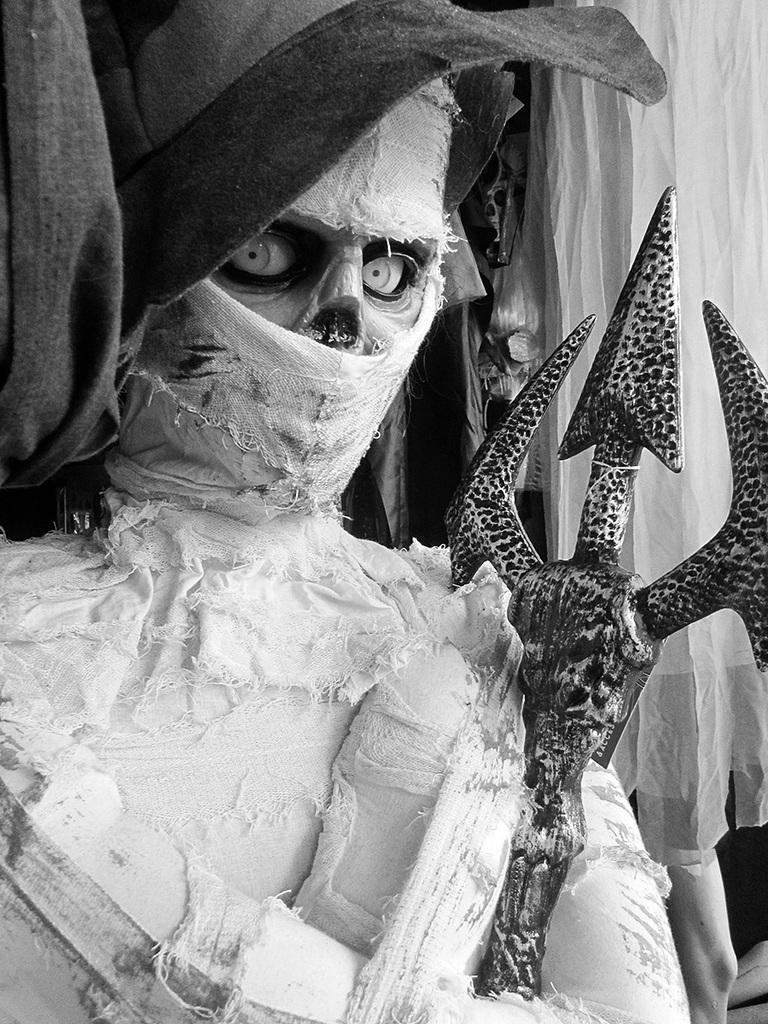What is the main subject of the image? There is a mummy in the image. What object can be seen in the image besides the mummy? There is a metal rod in the image. What type of bag is the mummy carrying in the image? There is no bag present in the image. Can you describe the mummy's romantic interaction with the metal rod in the image? There is no romantic interaction depicted in the image; it features a mummy and a metal rod. 